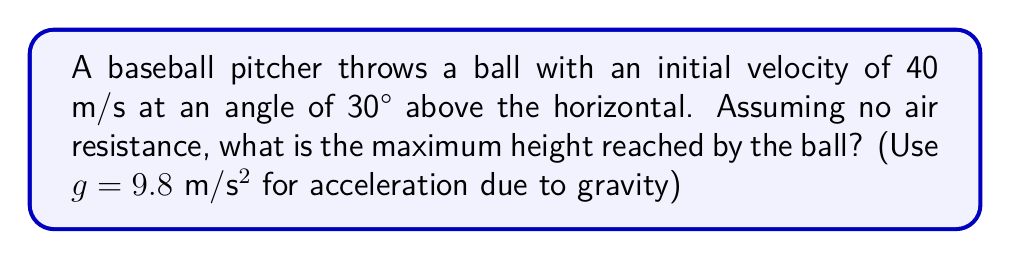Give your solution to this math problem. To solve this problem, we'll use trigonometric functions and the equations of motion for projectile motion. Let's break it down step-by-step:

1) The vertical component of the initial velocity is given by:
   $$v_y = v_0 \sin \theta = 40 \sin 30° = 20 \text{ m/s}$$

2) The maximum height is reached when the vertical velocity becomes zero. We can use the equation:
   $$v_y^2 = v_0^2 - 2gh_{max}$$
   where $v_y$ is the final vertical velocity (0 at the highest point), $v_0$ is the initial vertical velocity, $g$ is the acceleration due to gravity, and $h_{max}$ is the maximum height.

3) Substituting the known values:
   $$0^2 = 20^2 - 2(9.8)h_{max}$$

4) Simplifying:
   $$400 = 19.6h_{max}$$

5) Solving for $h_{max}$:
   $$h_{max} = \frac{400}{19.6} = 20.41 \text{ m}$$

Therefore, the maximum height reached by the ball is approximately 20.41 meters.
Answer: 20.41 m 